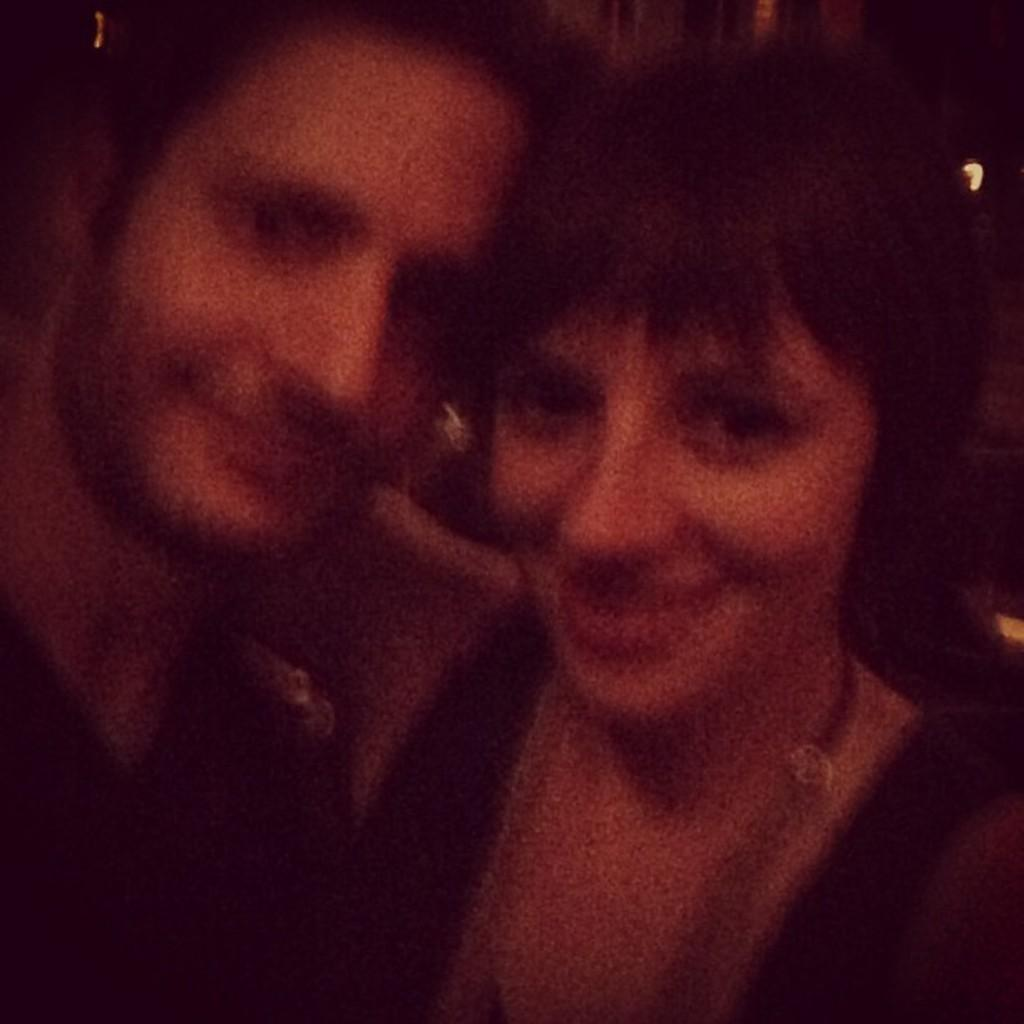How many people are in the image? There are two people in the image, a woman and a man. What are the woman and man doing in the image? A: The woman and man are giving a pose. What type of ticket does the carpenter have in the image? There is no carpenter or ticket present in the image. 